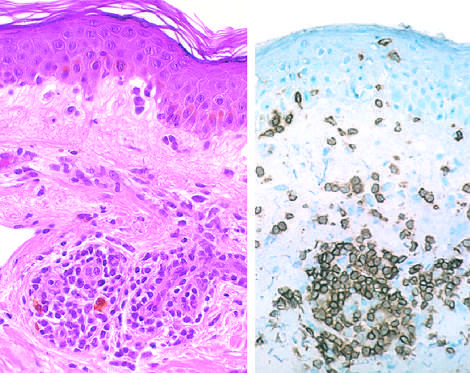what does immunoperoxidase staining reveal that marks positively with anti-cd4 antibodies?
Answer the question using a single word or phrase. A predominantly perivascular cellular infiltrate 